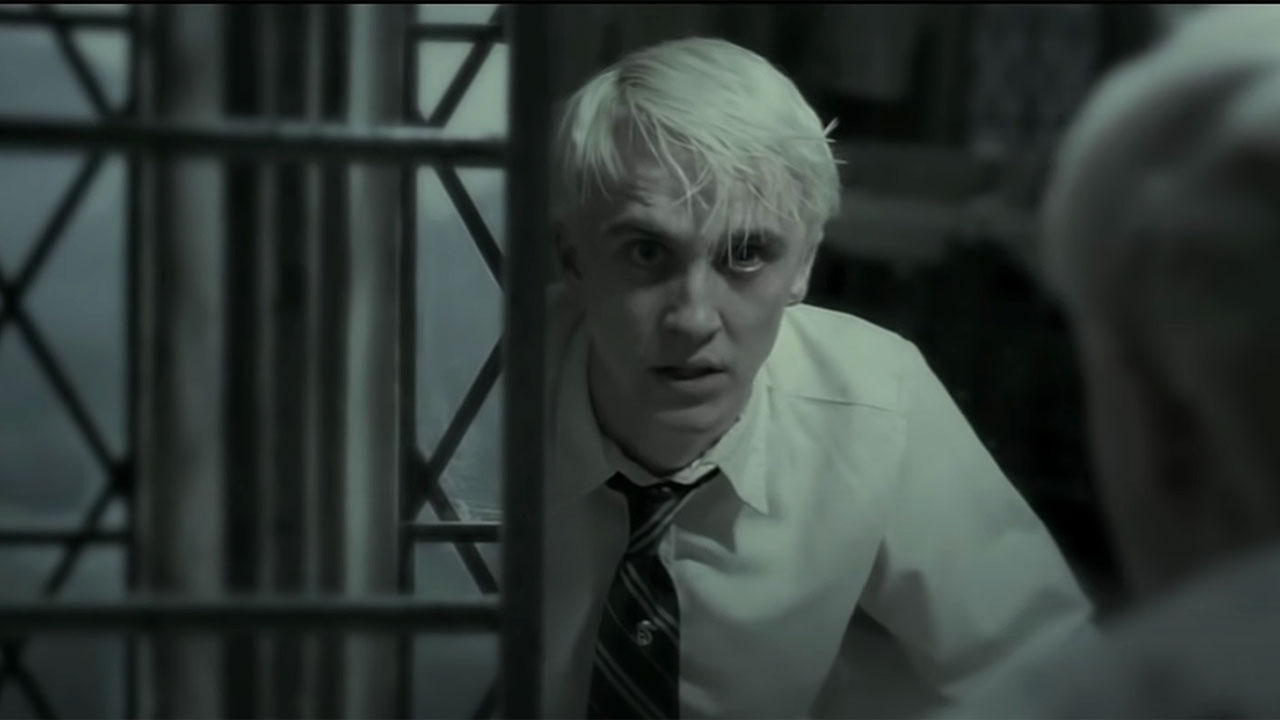Describe the mood conveyed in this image. The mood in this image is one of intense suspense and foreboding. Draco Malfoy's shocked and somewhat fearful expression, combined with the dark, grayscale tone of the image and the restrictive metal bars, creates a feeling of entrapment and anxiety. It's as if he's caught in a moment of realization or confrontation, heightening the emotional tension inherent in the scene. What could be happening off-screen to cause this reaction? Given Draco's expression, it is likely that he is witnessing or learning about something extremely alarming or disturbing off-screen. In the context of 'Harry Potter and the Half-Blood Prince,' this could be linked to a critical and dangerous mission assigned to him by Voldemort, heightening his fears and anxiety. Perhaps he sees something or someone that represents a threat to his safety or to the plans he’s supposed to carry out. 